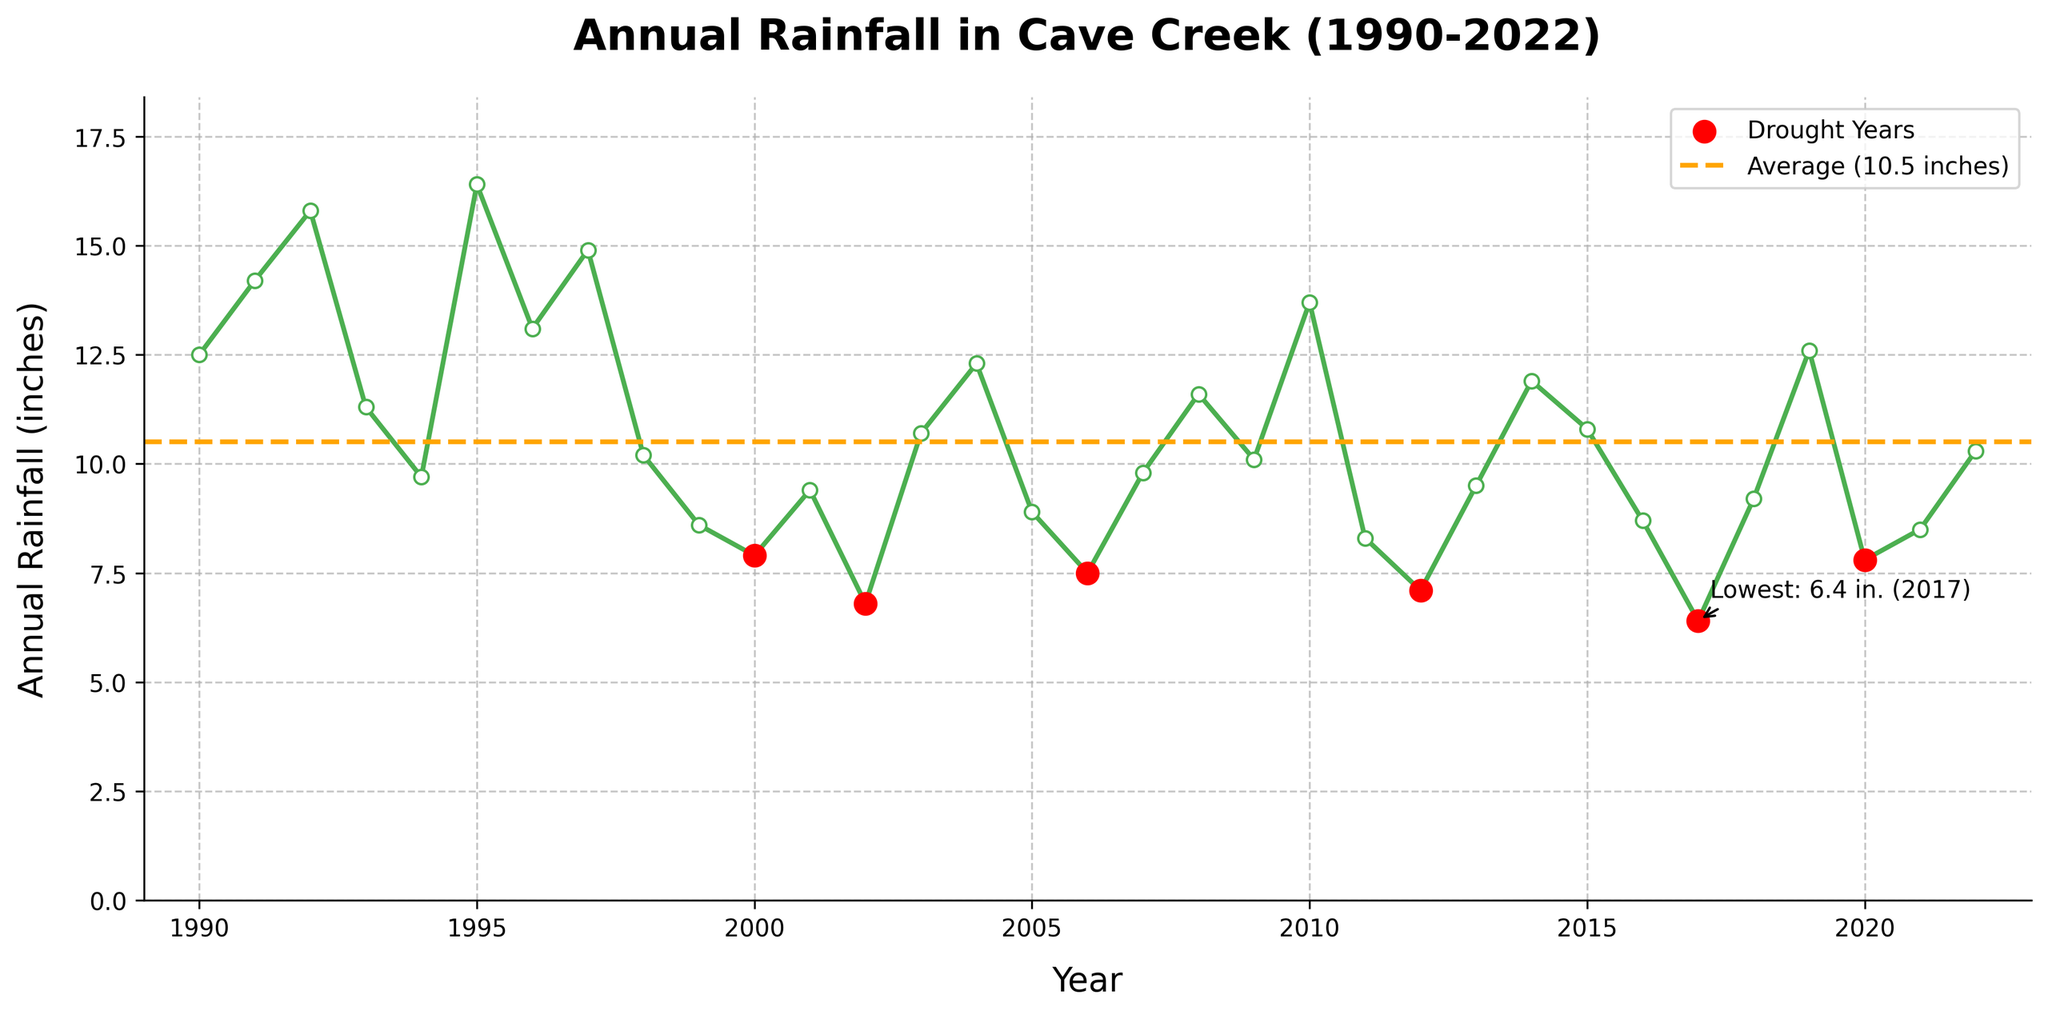What was the lowest annual rainfall recorded and in which year did it occur? The graph highlights the lowest annual rainfall mark with an annotation. It indicates the lowest recorded rainfall of 6.4 inches in 2017.
Answer: 6.4 inches, 2017 How many drought years (with rainfall < 8 inches) are shown on the chart? The chart marks drought years with red dots. By counting them, we identify the drought years as 1994, 1999, 2000, 2002, 2006, 2011, 2012, 2017, and 2020, making it a total of 9 drought years.
Answer: 9 Which year had the highest annual rainfall, and what was the amount? The peak point on the line representing the highest rainfall visually appears in 1995. The annotation indicates this year had the highest rainfall of 16.4 inches.
Answer: 1995, 16.4 inches What is the average rainfall over the period, and how does it compare to the rainfall in 2022? The chart includes a horizontal orange dotted line indicating the average rainfall over the period. The average rainfall is noted at 10.8 inches. Comparing this to the 2022 rainfall of 10.3 inches, we see that 2022’s rainfall was slightly below average.
Answer: Average: 10.8 inches, 2022: 10.3 inches Between which consecutive years did the rainfall decrease the most? To find the largest drop, compare consecutive rainfall values through the visual change in line slopes. The steepest part of the chart occurs between 2004 (12.3 inches) and 2005 (8.9 inches), where the decrease is 12.3 - 8.9 = 3.4 inches.
Answer: 2004 and 2005 How many times did the rainfall equal or exceed 14 inches? By observing the height of the rainfall line, it is evident on multiple peaks. The years where rainfall equaled or exceeded 14 inches are: 1991, 1992, 1995, 1997, and 2010—making it a total of 5 instances.
Answer: 5 times In which years were the increases in annual rainfall consecutive for at least three years? The periods of consistent increase in rainfall over years can be checked by looking at rising line segments. The most evident streak appears between 2020 (7.8 inches), 2021 (8.5 inches), and 2022 (10.3 inches), lasting for three years.
Answer: 2020-2022 What visual feature indicates the average rainfall on the chart, and what is its significance? The average rainfall is represented by an orange horizontal dashed line that runs across the chart at 10.8 inches, signifying the overall mean annual rainfall over the entire period and used as a benchmark for comparison.
Answer: Orange dashed line at 10.8 inches Comparing the first five years and the last five years in the dataset, which period had higher average rainfall? Calculate the average of the first five years (1990-1994): (12.5 + 14.2 + 15.8 + 11.3 + 9.7) / 5 = 12.7 inches. For the last five years (2018-2022): (9.2 + 12.6 + 7.8 + 8.5 + 10.3) / 5 = 9.68 inches. The first five years had a higher average.
Answer: First five years How does the rainfall in 2005 compare to that in 2006? From visual inspection, the rainfall in 2005 is 8.9 inches, and in 2006 is 7.5 inches. The rainfall in 2005 is higher by 1.4 inches compared to 2006.
Answer: 2005 is higher 